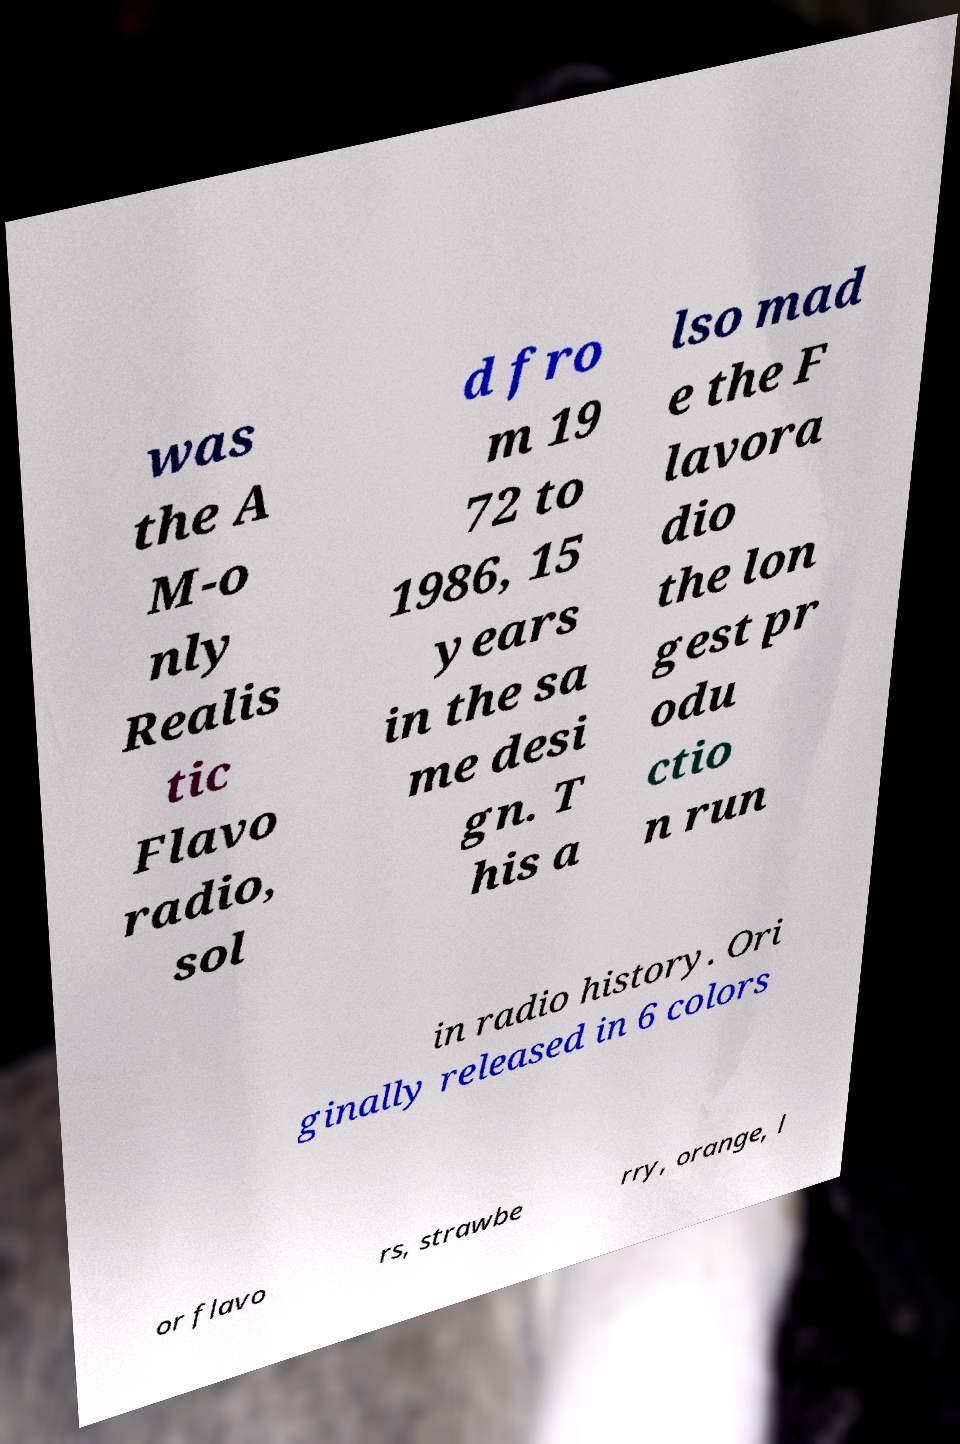Can you read and provide the text displayed in the image?This photo seems to have some interesting text. Can you extract and type it out for me? was the A M-o nly Realis tic Flavo radio, sol d fro m 19 72 to 1986, 15 years in the sa me desi gn. T his a lso mad e the F lavora dio the lon gest pr odu ctio n run in radio history. Ori ginally released in 6 colors or flavo rs, strawbe rry, orange, l 